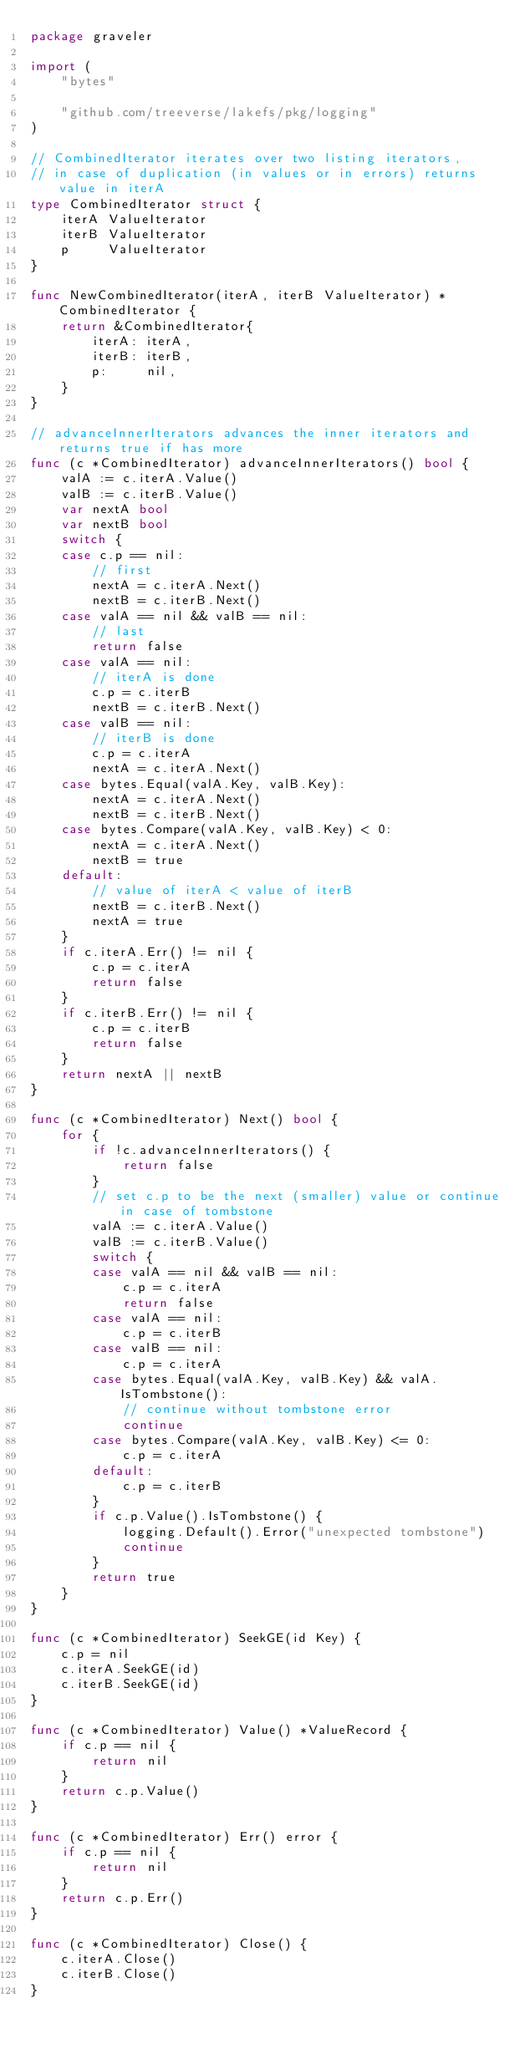<code> <loc_0><loc_0><loc_500><loc_500><_Go_>package graveler

import (
	"bytes"

	"github.com/treeverse/lakefs/pkg/logging"
)

// CombinedIterator iterates over two listing iterators,
// in case of duplication (in values or in errors) returns value in iterA
type CombinedIterator struct {
	iterA ValueIterator
	iterB ValueIterator
	p     ValueIterator
}

func NewCombinedIterator(iterA, iterB ValueIterator) *CombinedIterator {
	return &CombinedIterator{
		iterA: iterA,
		iterB: iterB,
		p:     nil,
	}
}

// advanceInnerIterators advances the inner iterators and returns true if has more
func (c *CombinedIterator) advanceInnerIterators() bool {
	valA := c.iterA.Value()
	valB := c.iterB.Value()
	var nextA bool
	var nextB bool
	switch {
	case c.p == nil:
		// first
		nextA = c.iterA.Next()
		nextB = c.iterB.Next()
	case valA == nil && valB == nil:
		// last
		return false
	case valA == nil:
		// iterA is done
		c.p = c.iterB
		nextB = c.iterB.Next()
	case valB == nil:
		// iterB is done
		c.p = c.iterA
		nextA = c.iterA.Next()
	case bytes.Equal(valA.Key, valB.Key):
		nextA = c.iterA.Next()
		nextB = c.iterB.Next()
	case bytes.Compare(valA.Key, valB.Key) < 0:
		nextA = c.iterA.Next()
		nextB = true
	default:
		// value of iterA < value of iterB
		nextB = c.iterB.Next()
		nextA = true
	}
	if c.iterA.Err() != nil {
		c.p = c.iterA
		return false
	}
	if c.iterB.Err() != nil {
		c.p = c.iterB
		return false
	}
	return nextA || nextB
}

func (c *CombinedIterator) Next() bool {
	for {
		if !c.advanceInnerIterators() {
			return false
		}
		// set c.p to be the next (smaller) value or continue in case of tombstone
		valA := c.iterA.Value()
		valB := c.iterB.Value()
		switch {
		case valA == nil && valB == nil:
			c.p = c.iterA
			return false
		case valA == nil:
			c.p = c.iterB
		case valB == nil:
			c.p = c.iterA
		case bytes.Equal(valA.Key, valB.Key) && valA.IsTombstone():
			// continue without tombstone error
			continue
		case bytes.Compare(valA.Key, valB.Key) <= 0:
			c.p = c.iterA
		default:
			c.p = c.iterB
		}
		if c.p.Value().IsTombstone() {
			logging.Default().Error("unexpected tombstone")
			continue
		}
		return true
	}
}

func (c *CombinedIterator) SeekGE(id Key) {
	c.p = nil
	c.iterA.SeekGE(id)
	c.iterB.SeekGE(id)
}

func (c *CombinedIterator) Value() *ValueRecord {
	if c.p == nil {
		return nil
	}
	return c.p.Value()
}

func (c *CombinedIterator) Err() error {
	if c.p == nil {
		return nil
	}
	return c.p.Err()
}

func (c *CombinedIterator) Close() {
	c.iterA.Close()
	c.iterB.Close()
}
</code> 